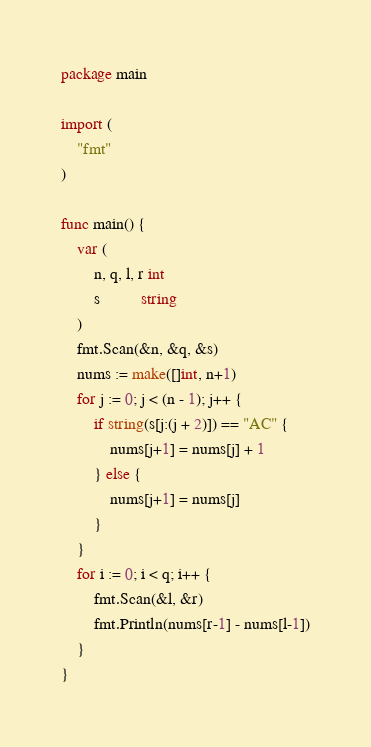Convert code to text. <code><loc_0><loc_0><loc_500><loc_500><_Go_>package main

import (
	"fmt"
)

func main() {
	var (
		n, q, l, r int
		s          string
	)
	fmt.Scan(&n, &q, &s)
	nums := make([]int, n+1)
	for j := 0; j < (n - 1); j++ {
		if string(s[j:(j + 2)]) == "AC" {
			nums[j+1] = nums[j] + 1
		} else {
			nums[j+1] = nums[j]
		}
	}
	for i := 0; i < q; i++ {
		fmt.Scan(&l, &r)
		fmt.Println(nums[r-1] - nums[l-1])
	}
}
</code> 